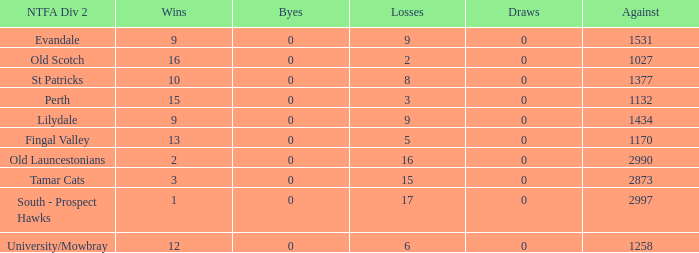What is the lowest number of draws of the team with 9 wins and less than 0 byes? None. 